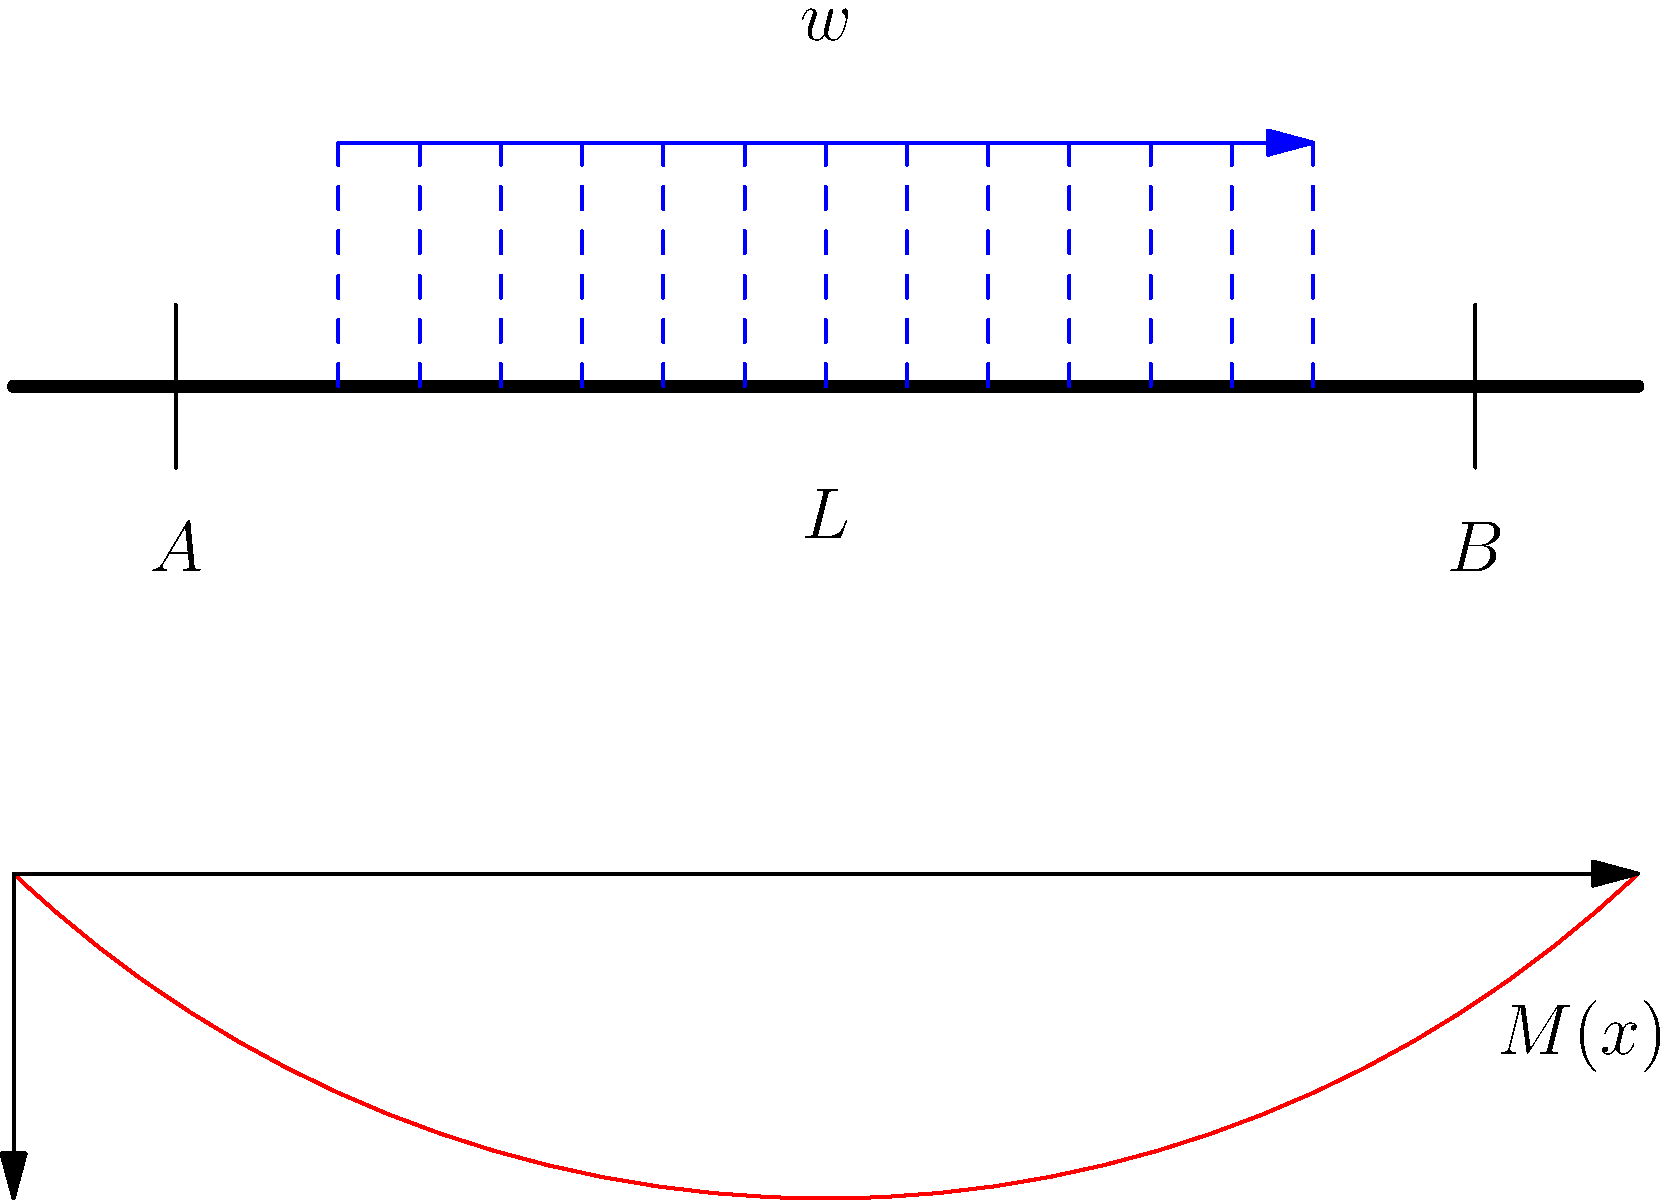A simply supported beam of length $L$ is subjected to a uniformly distributed load $w$ over its entire span. Determine the expression for the bending moment $M(x)$ at any point $x$ along the beam, and identify the location and magnitude of the maximum bending moment. To solve this problem, we'll follow these steps:

1) First, let's determine the reaction forces at the supports:
   Due to symmetry, $R_A = R_B = \frac{wL}{2}$

2) The bending moment at any point $x$ can be found by considering the forces to the left of $x$:
   $M(x) = R_A \cdot x - w \cdot x \cdot \frac{x}{2}$

3) Substituting the value of $R_A$:
   $M(x) = \frac{wL}{2} \cdot x - w \cdot \frac{x^2}{2}$

4) Simplifying:
   $M(x) = \frac{wx}{2}(L-x)$

5) To find the maximum bending moment, we differentiate $M(x)$ with respect to $x$ and set it to zero:
   $\frac{dM}{dx} = \frac{w}{2}(L-2x) = 0$

6) Solving for $x$:
   $L-2x = 0$
   $x = \frac{L}{2}$

7) The maximum bending moment occurs at the middle of the beam $(x=\frac{L}{2})$. To find its magnitude, we substitute this value back into our moment equation:

   $M_{max} = M(\frac{L}{2}) = \frac{w(\frac{L}{2})}{2}(L-\frac{L}{2}) = \frac{wL^2}{8}$

Therefore, the bending moment at any point $x$ is given by $M(x) = \frac{wx}{2}(L-x)$, and the maximum bending moment occurs at the middle of the beam with a magnitude of $\frac{wL^2}{8}$.
Answer: $M(x) = \frac{wx}{2}(L-x)$; Max at $x=\frac{L}{2}$; $M_{max} = \frac{wL^2}{8}$ 